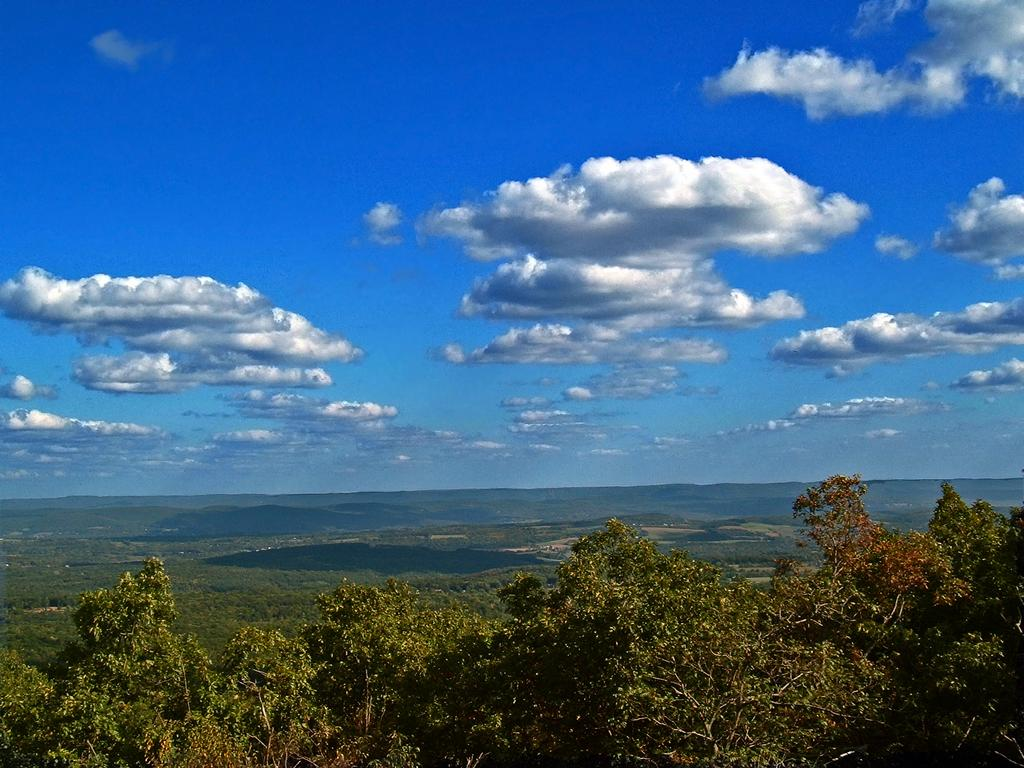What type of vegetation can be seen in the image? There are trees in the image. What colors are the trees in the image? The trees are green and brown in color. What is visible in the background of the image? There is ground, water, mountains, and the sky visible in the background of the image. How many zebras can be seen grazing on the level ground in the image? There are no zebras present in the image; it features trees, ground, water, mountains, and the sky. What type of bird is visible in the image? There is no bird, specifically a turkey, visible in the image. 